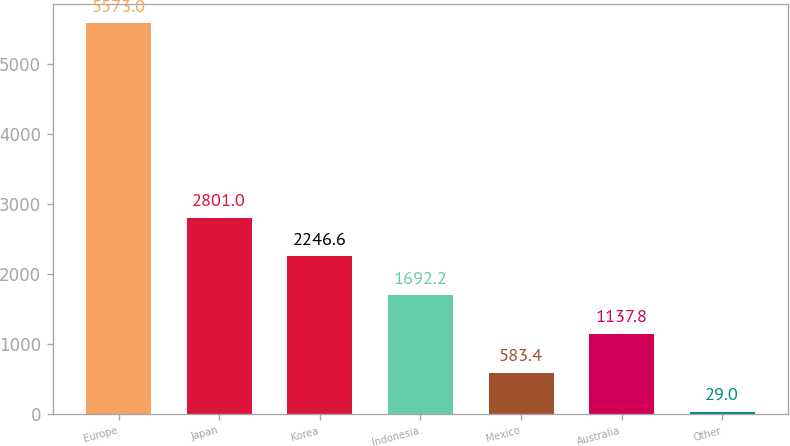<chart> <loc_0><loc_0><loc_500><loc_500><bar_chart><fcel>Europe<fcel>Japan<fcel>Korea<fcel>Indonesia<fcel>Mexico<fcel>Australia<fcel>Other<nl><fcel>5573<fcel>2801<fcel>2246.6<fcel>1692.2<fcel>583.4<fcel>1137.8<fcel>29<nl></chart> 